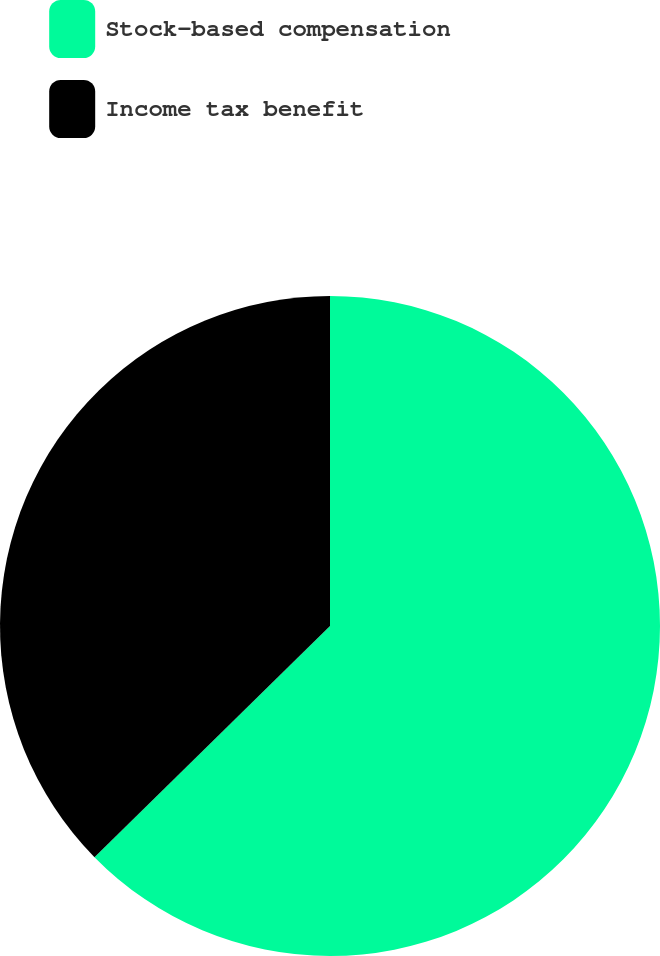<chart> <loc_0><loc_0><loc_500><loc_500><pie_chart><fcel>Stock-based compensation<fcel>Income tax benefit<nl><fcel>62.65%<fcel>37.35%<nl></chart> 